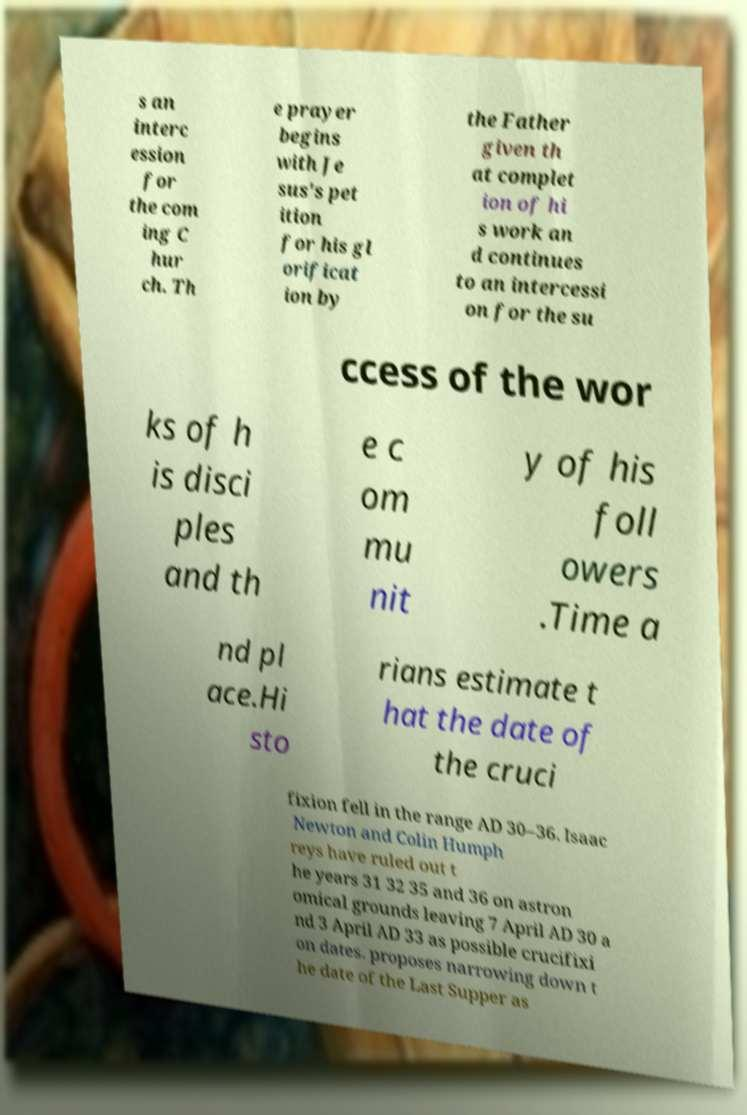Please identify and transcribe the text found in this image. s an interc ession for the com ing C hur ch. Th e prayer begins with Je sus's pet ition for his gl orificat ion by the Father given th at complet ion of hi s work an d continues to an intercessi on for the su ccess of the wor ks of h is disci ples and th e c om mu nit y of his foll owers .Time a nd pl ace.Hi sto rians estimate t hat the date of the cruci fixion fell in the range AD 30–36. Isaac Newton and Colin Humph reys have ruled out t he years 31 32 35 and 36 on astron omical grounds leaving 7 April AD 30 a nd 3 April AD 33 as possible crucifixi on dates. proposes narrowing down t he date of the Last Supper as 